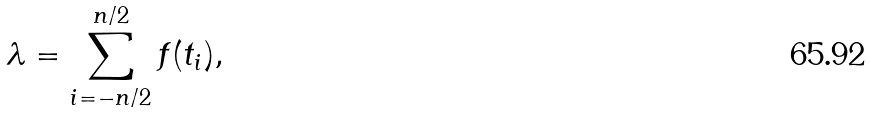Convert formula to latex. <formula><loc_0><loc_0><loc_500><loc_500>\lambda = \sum _ { i = - n / 2 } ^ { n / 2 } f ( t _ { i } ) ,</formula> 